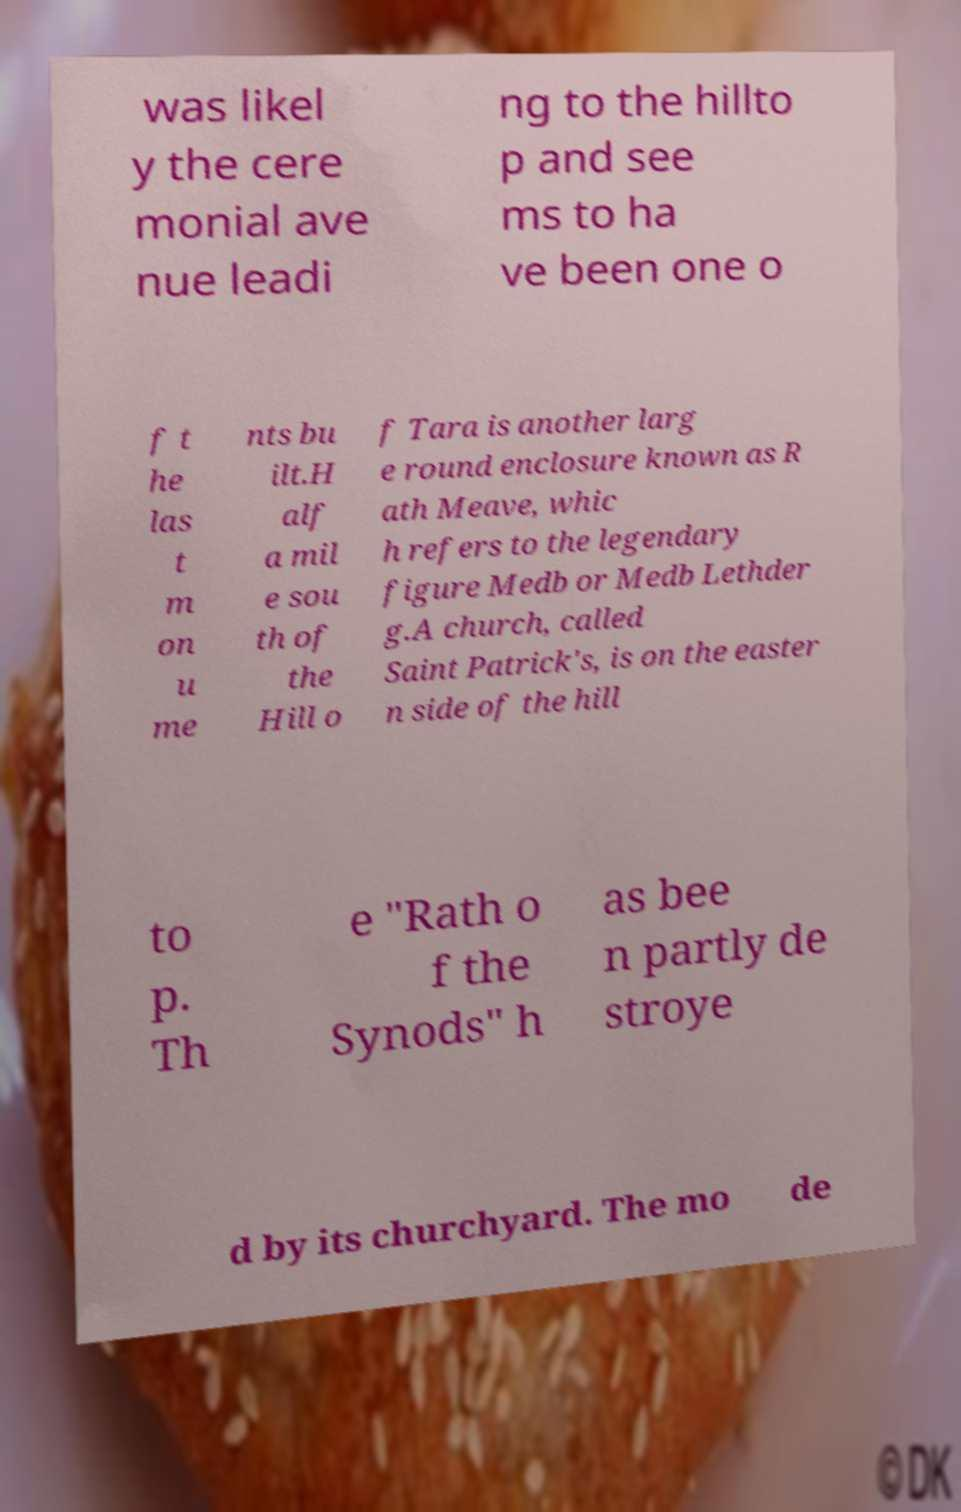Please identify and transcribe the text found in this image. was likel y the cere monial ave nue leadi ng to the hillto p and see ms to ha ve been one o f t he las t m on u me nts bu ilt.H alf a mil e sou th of the Hill o f Tara is another larg e round enclosure known as R ath Meave, whic h refers to the legendary figure Medb or Medb Lethder g.A church, called Saint Patrick's, is on the easter n side of the hill to p. Th e "Rath o f the Synods" h as bee n partly de stroye d by its churchyard. The mo de 